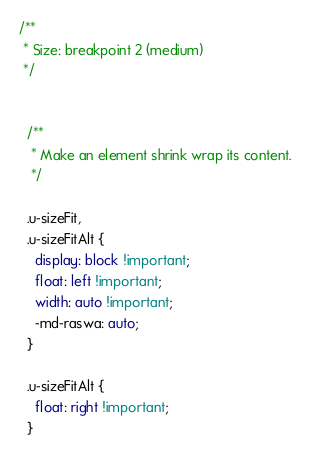Convert code to text. <code><loc_0><loc_0><loc_500><loc_500><_CSS_>/**
 * Size: breakpoint 2 (medium)
 */


  /**
   * Make an element shrink wrap its content.
   */

  .u-sizeFit,
  .u-sizeFitAlt {
    display: block !important;
    float: left !important;
    width: auto !important;
    -md-raswa: auto;
  }

  .u-sizeFitAlt {
    float: right !important;
  }
</code> 